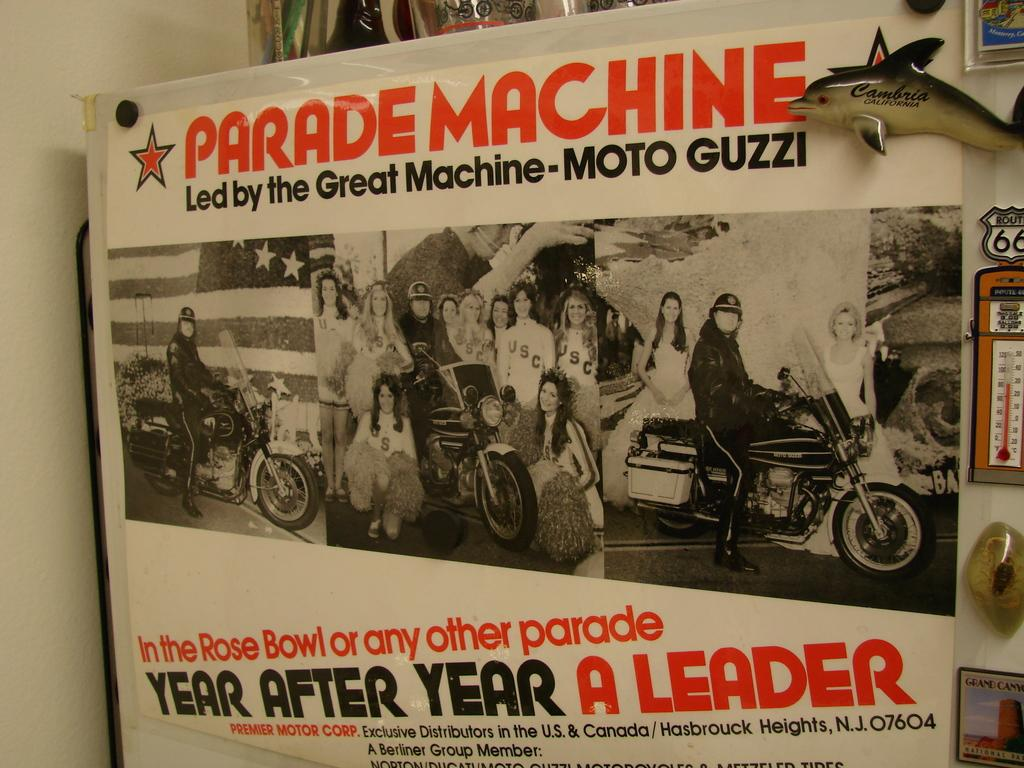Provide a one-sentence caption for the provided image. A white poster in black and orange writing that says "Parade Machine led by the Great Machine- Moto Guzzi.". 